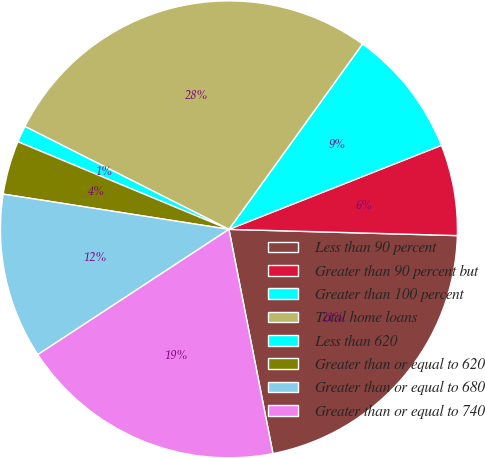<chart> <loc_0><loc_0><loc_500><loc_500><pie_chart><fcel>Less than 90 percent<fcel>Greater than 90 percent but<fcel>Greater than 100 percent<fcel>Total home loans<fcel>Less than 620<fcel>Greater than or equal to 620<fcel>Greater than or equal to 680<fcel>Greater than or equal to 740<nl><fcel>21.48%<fcel>6.43%<fcel>9.07%<fcel>27.5%<fcel>1.17%<fcel>3.8%<fcel>11.7%<fcel>18.85%<nl></chart> 